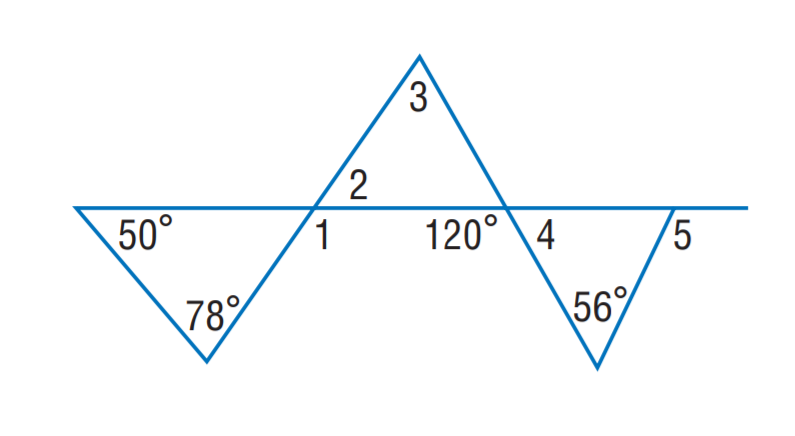Answer the mathemtical geometry problem and directly provide the correct option letter.
Question: Find m \angle 2.
Choices: A: 50 B: 52 C: 56 D: 68 B 